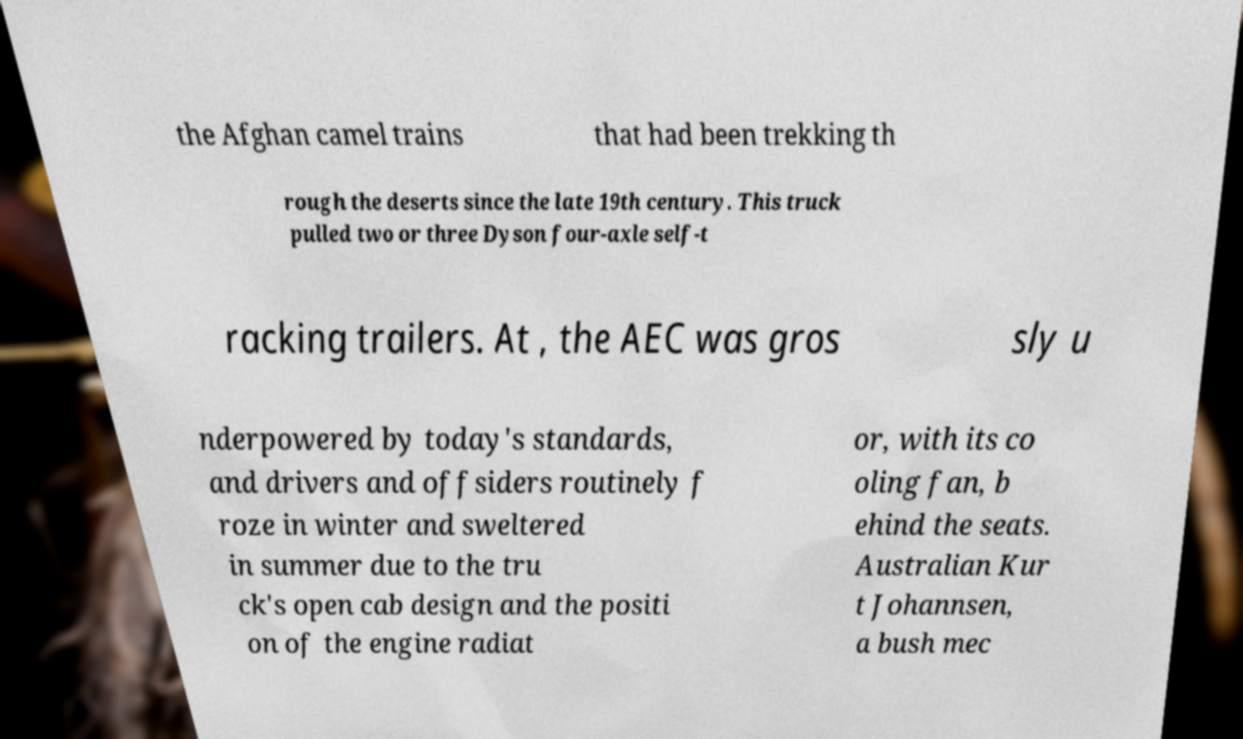Please read and relay the text visible in this image. What does it say? the Afghan camel trains that had been trekking th rough the deserts since the late 19th century. This truck pulled two or three Dyson four-axle self-t racking trailers. At , the AEC was gros sly u nderpowered by today's standards, and drivers and offsiders routinely f roze in winter and sweltered in summer due to the tru ck's open cab design and the positi on of the engine radiat or, with its co oling fan, b ehind the seats. Australian Kur t Johannsen, a bush mec 